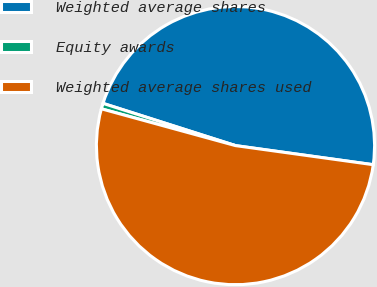<chart> <loc_0><loc_0><loc_500><loc_500><pie_chart><fcel>Weighted average shares<fcel>Equity awards<fcel>Weighted average shares used<nl><fcel>47.28%<fcel>0.65%<fcel>52.07%<nl></chart> 